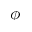<formula> <loc_0><loc_0><loc_500><loc_500>\phi</formula> 